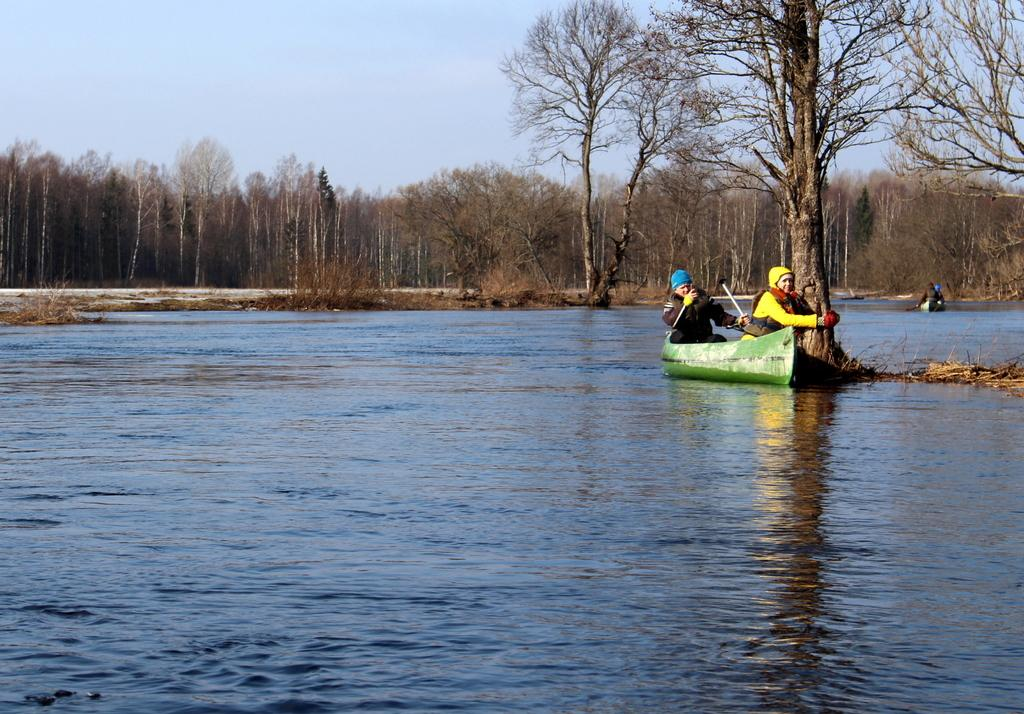What activity are the two persons engaged in on the right side of the image? The two persons are floating on a boat on the right side of the image. What type of vegetation is present at the center of the image? There are trees at the center of the image. What can be seen in the background of the image? There is a sky visible in the background of the image. What type of account is being used by the persons on the boat to access their funds? There is no information about any accounts or funds in the image; it only shows two persons floating on a boat and trees at the center. 